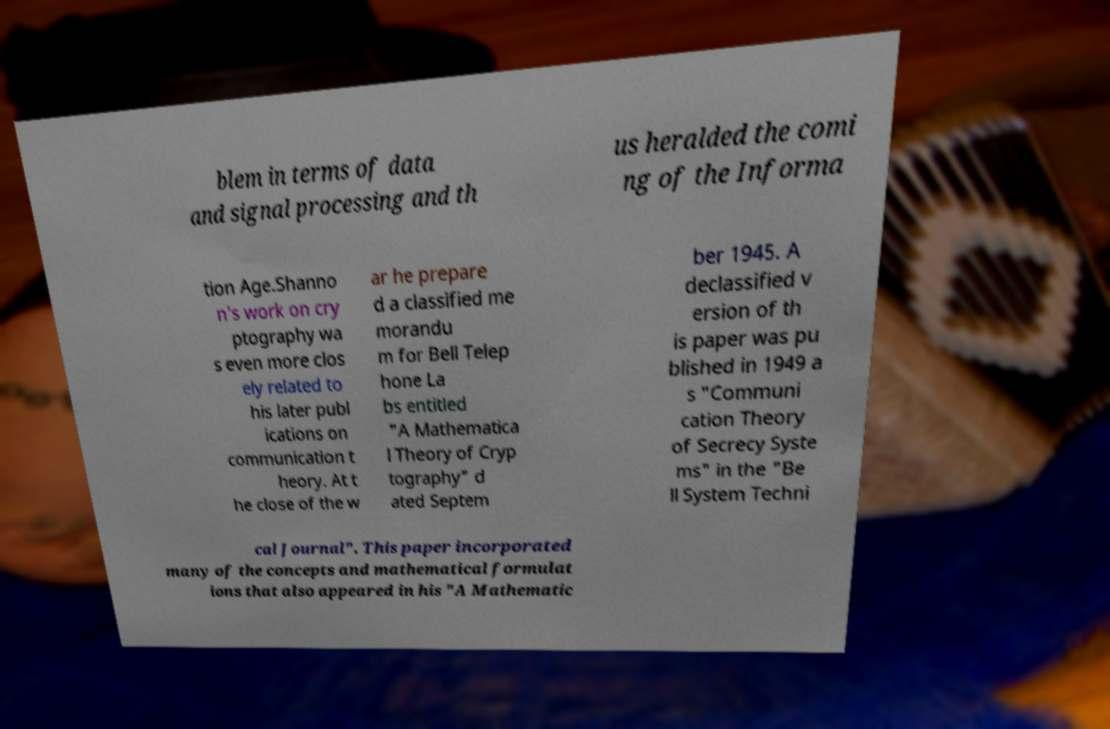Could you extract and type out the text from this image? blem in terms of data and signal processing and th us heralded the comi ng of the Informa tion Age.Shanno n's work on cry ptography wa s even more clos ely related to his later publ ications on communication t heory. At t he close of the w ar he prepare d a classified me morandu m for Bell Telep hone La bs entitled "A Mathematica l Theory of Cryp tography" d ated Septem ber 1945. A declassified v ersion of th is paper was pu blished in 1949 a s "Communi cation Theory of Secrecy Syste ms" in the "Be ll System Techni cal Journal". This paper incorporated many of the concepts and mathematical formulat ions that also appeared in his "A Mathematic 